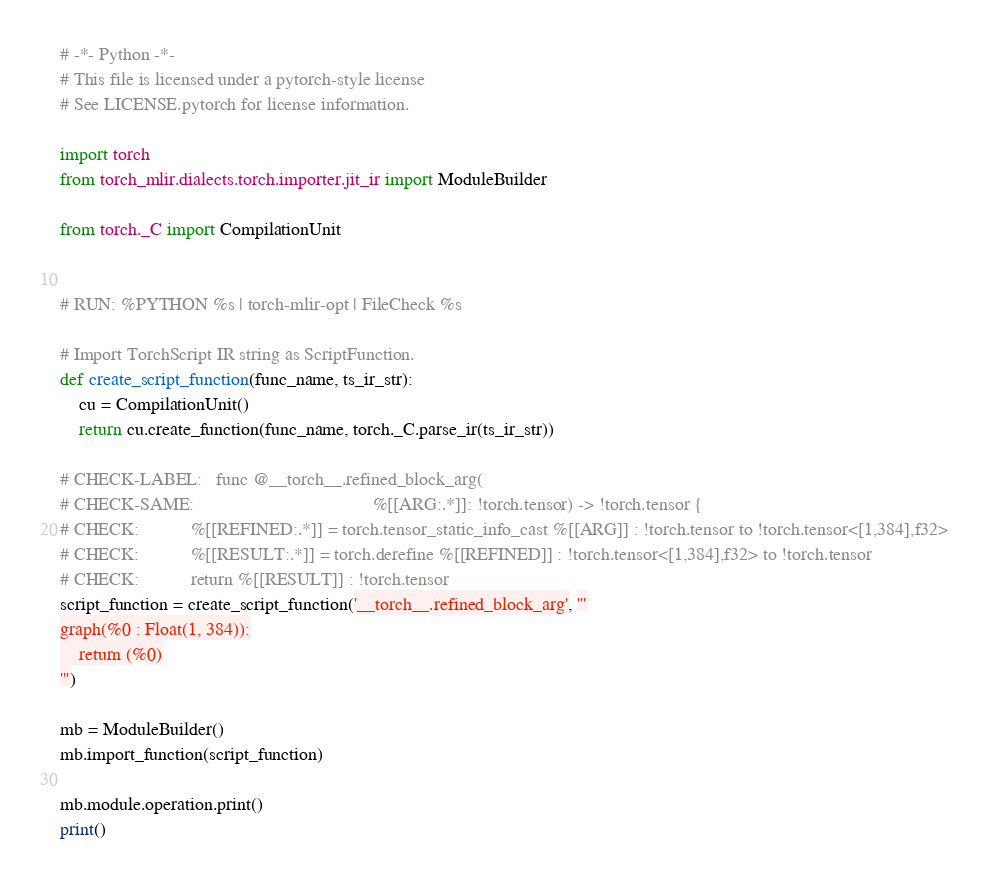Convert code to text. <code><loc_0><loc_0><loc_500><loc_500><_Python_># -*- Python -*-
# This file is licensed under a pytorch-style license
# See LICENSE.pytorch for license information.

import torch
from torch_mlir.dialects.torch.importer.jit_ir import ModuleBuilder

from torch._C import CompilationUnit


# RUN: %PYTHON %s | torch-mlir-opt | FileCheck %s

# Import TorchScript IR string as ScriptFunction.
def create_script_function(func_name, ts_ir_str):
    cu = CompilationUnit()
    return cu.create_function(func_name, torch._C.parse_ir(ts_ir_str))

# CHECK-LABEL:   func @__torch__.refined_block_arg(
# CHECK-SAME:                                      %[[ARG:.*]]: !torch.tensor) -> !torch.tensor {
# CHECK:           %[[REFINED:.*]] = torch.tensor_static_info_cast %[[ARG]] : !torch.tensor to !torch.tensor<[1,384],f32>
# CHECK:           %[[RESULT:.*]] = torch.derefine %[[REFINED]] : !torch.tensor<[1,384],f32> to !torch.tensor
# CHECK:           return %[[RESULT]] : !torch.tensor
script_function = create_script_function('__torch__.refined_block_arg', '''
graph(%0 : Float(1, 384)):
    return (%0)
''')

mb = ModuleBuilder()
mb.import_function(script_function)

mb.module.operation.print()
print()
</code> 